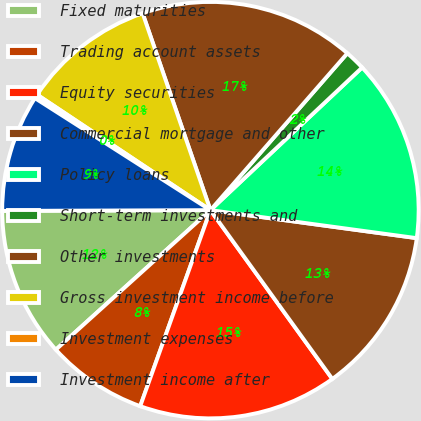<chart> <loc_0><loc_0><loc_500><loc_500><pie_chart><fcel>Fixed maturities<fcel>Trading account assets<fcel>Equity securities<fcel>Commercial mortgage and other<fcel>Policy loans<fcel>Short-term investments and<fcel>Other investments<fcel>Gross investment income before<fcel>Investment expenses<fcel>Investment income after<nl><fcel>11.63%<fcel>7.84%<fcel>15.43%<fcel>12.9%<fcel>14.16%<fcel>1.57%<fcel>16.7%<fcel>10.37%<fcel>0.31%<fcel>9.1%<nl></chart> 